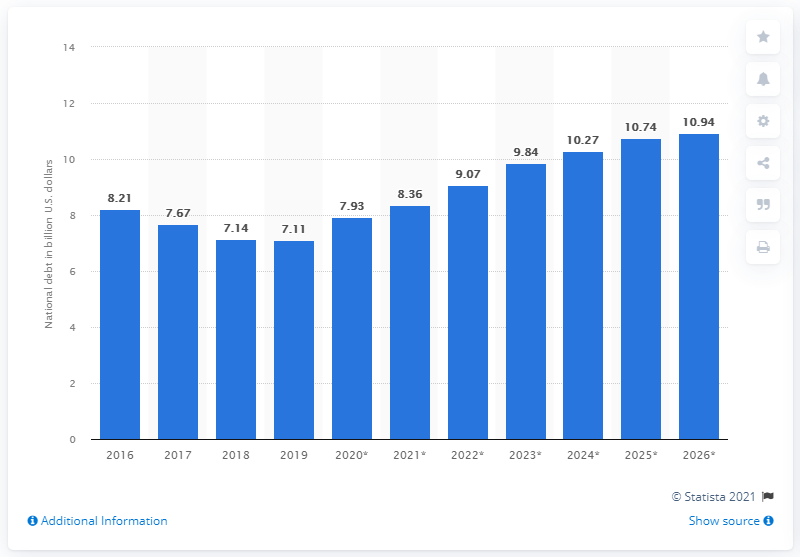List a handful of essential elements in this visual. In 2019, the national debt of Bosnia and Herzegovina was approximately 7.11 billion dollars. 